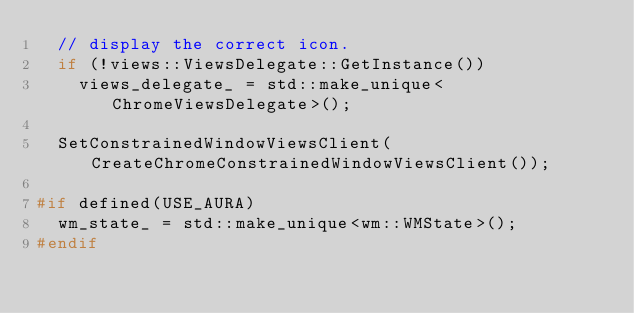Convert code to text. <code><loc_0><loc_0><loc_500><loc_500><_C++_>  // display the correct icon.
  if (!views::ViewsDelegate::GetInstance())
    views_delegate_ = std::make_unique<ChromeViewsDelegate>();

  SetConstrainedWindowViewsClient(CreateChromeConstrainedWindowViewsClient());

#if defined(USE_AURA)
  wm_state_ = std::make_unique<wm::WMState>();
#endif
</code> 